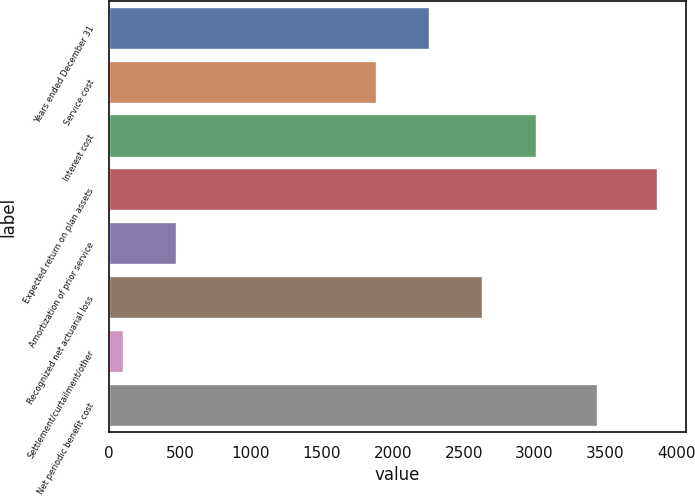Convert chart to OTSL. <chart><loc_0><loc_0><loc_500><loc_500><bar_chart><fcel>Years ended December 31<fcel>Service cost<fcel>Interest cost<fcel>Expected return on plan assets<fcel>Amortization of prior service<fcel>Recognized net actuarial loss<fcel>Settlement/curtailment/other<fcel>Net periodic benefit cost<nl><fcel>2263<fcel>1886<fcel>3017<fcel>3874<fcel>481<fcel>2640<fcel>104<fcel>3449<nl></chart> 